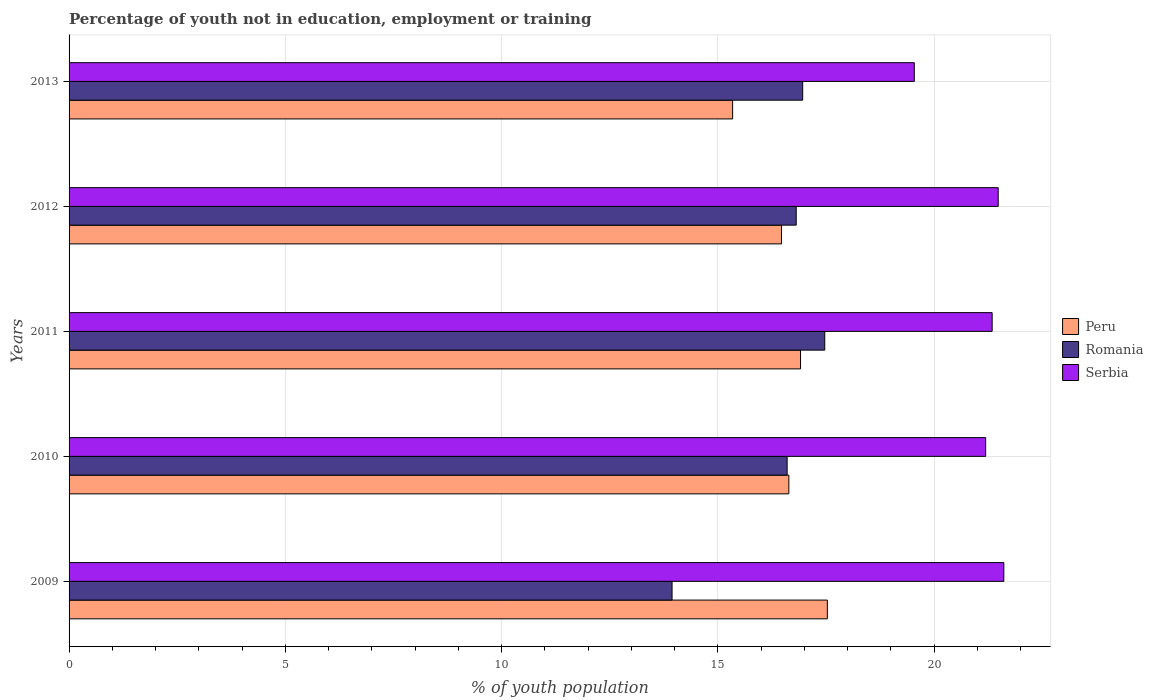How many different coloured bars are there?
Keep it short and to the point. 3. Are the number of bars per tick equal to the number of legend labels?
Provide a short and direct response. Yes. Are the number of bars on each tick of the Y-axis equal?
Offer a terse response. Yes. How many bars are there on the 3rd tick from the top?
Offer a terse response. 3. What is the percentage of unemployed youth population in in Peru in 2009?
Your answer should be very brief. 17.53. Across all years, what is the maximum percentage of unemployed youth population in in Peru?
Your response must be concise. 17.53. Across all years, what is the minimum percentage of unemployed youth population in in Peru?
Your answer should be very brief. 15.34. In which year was the percentage of unemployed youth population in in Peru maximum?
Make the answer very short. 2009. In which year was the percentage of unemployed youth population in in Serbia minimum?
Make the answer very short. 2013. What is the total percentage of unemployed youth population in in Peru in the graph?
Offer a terse response. 82.89. What is the difference between the percentage of unemployed youth population in in Peru in 2009 and that in 2010?
Give a very brief answer. 0.89. What is the difference between the percentage of unemployed youth population in in Romania in 2009 and the percentage of unemployed youth population in in Serbia in 2013?
Your answer should be very brief. -5.6. What is the average percentage of unemployed youth population in in Serbia per year?
Ensure brevity in your answer.  21.03. In the year 2011, what is the difference between the percentage of unemployed youth population in in Serbia and percentage of unemployed youth population in in Peru?
Keep it short and to the point. 4.43. In how many years, is the percentage of unemployed youth population in in Serbia greater than 6 %?
Your answer should be compact. 5. What is the ratio of the percentage of unemployed youth population in in Serbia in 2009 to that in 2012?
Your answer should be very brief. 1.01. What is the difference between the highest and the second highest percentage of unemployed youth population in in Serbia?
Your answer should be very brief. 0.13. What is the difference between the highest and the lowest percentage of unemployed youth population in in Serbia?
Make the answer very short. 2.07. In how many years, is the percentage of unemployed youth population in in Serbia greater than the average percentage of unemployed youth population in in Serbia taken over all years?
Provide a short and direct response. 4. Is the sum of the percentage of unemployed youth population in in Serbia in 2011 and 2012 greater than the maximum percentage of unemployed youth population in in Romania across all years?
Make the answer very short. Yes. What does the 2nd bar from the top in 2012 represents?
Ensure brevity in your answer.  Romania. What does the 3rd bar from the bottom in 2010 represents?
Offer a terse response. Serbia. How many bars are there?
Your answer should be very brief. 15. How many years are there in the graph?
Your response must be concise. 5. What is the difference between two consecutive major ticks on the X-axis?
Offer a terse response. 5. Does the graph contain any zero values?
Your answer should be compact. No. Does the graph contain grids?
Provide a short and direct response. Yes. How many legend labels are there?
Your answer should be very brief. 3. How are the legend labels stacked?
Your response must be concise. Vertical. What is the title of the graph?
Give a very brief answer. Percentage of youth not in education, employment or training. What is the label or title of the X-axis?
Provide a short and direct response. % of youth population. What is the label or title of the Y-axis?
Your response must be concise. Years. What is the % of youth population in Peru in 2009?
Give a very brief answer. 17.53. What is the % of youth population of Romania in 2009?
Offer a very short reply. 13.94. What is the % of youth population in Serbia in 2009?
Provide a succinct answer. 21.61. What is the % of youth population in Peru in 2010?
Offer a terse response. 16.64. What is the % of youth population in Romania in 2010?
Offer a terse response. 16.6. What is the % of youth population of Serbia in 2010?
Provide a short and direct response. 21.19. What is the % of youth population in Peru in 2011?
Provide a short and direct response. 16.91. What is the % of youth population in Romania in 2011?
Your answer should be very brief. 17.47. What is the % of youth population of Serbia in 2011?
Your answer should be very brief. 21.34. What is the % of youth population of Peru in 2012?
Your answer should be compact. 16.47. What is the % of youth population of Romania in 2012?
Offer a very short reply. 16.81. What is the % of youth population of Serbia in 2012?
Offer a very short reply. 21.48. What is the % of youth population in Peru in 2013?
Make the answer very short. 15.34. What is the % of youth population in Romania in 2013?
Your answer should be very brief. 16.96. What is the % of youth population in Serbia in 2013?
Your answer should be very brief. 19.54. Across all years, what is the maximum % of youth population in Peru?
Your answer should be compact. 17.53. Across all years, what is the maximum % of youth population in Romania?
Keep it short and to the point. 17.47. Across all years, what is the maximum % of youth population of Serbia?
Ensure brevity in your answer.  21.61. Across all years, what is the minimum % of youth population in Peru?
Provide a short and direct response. 15.34. Across all years, what is the minimum % of youth population in Romania?
Keep it short and to the point. 13.94. Across all years, what is the minimum % of youth population of Serbia?
Offer a terse response. 19.54. What is the total % of youth population of Peru in the graph?
Offer a terse response. 82.89. What is the total % of youth population of Romania in the graph?
Your answer should be compact. 81.78. What is the total % of youth population of Serbia in the graph?
Make the answer very short. 105.16. What is the difference between the % of youth population of Peru in 2009 and that in 2010?
Give a very brief answer. 0.89. What is the difference between the % of youth population of Romania in 2009 and that in 2010?
Keep it short and to the point. -2.66. What is the difference between the % of youth population in Serbia in 2009 and that in 2010?
Make the answer very short. 0.42. What is the difference between the % of youth population of Peru in 2009 and that in 2011?
Give a very brief answer. 0.62. What is the difference between the % of youth population of Romania in 2009 and that in 2011?
Offer a terse response. -3.53. What is the difference between the % of youth population in Serbia in 2009 and that in 2011?
Ensure brevity in your answer.  0.27. What is the difference between the % of youth population in Peru in 2009 and that in 2012?
Your answer should be compact. 1.06. What is the difference between the % of youth population of Romania in 2009 and that in 2012?
Your response must be concise. -2.87. What is the difference between the % of youth population of Serbia in 2009 and that in 2012?
Keep it short and to the point. 0.13. What is the difference between the % of youth population in Peru in 2009 and that in 2013?
Provide a short and direct response. 2.19. What is the difference between the % of youth population in Romania in 2009 and that in 2013?
Your answer should be compact. -3.02. What is the difference between the % of youth population in Serbia in 2009 and that in 2013?
Provide a short and direct response. 2.07. What is the difference between the % of youth population in Peru in 2010 and that in 2011?
Give a very brief answer. -0.27. What is the difference between the % of youth population of Romania in 2010 and that in 2011?
Offer a terse response. -0.87. What is the difference between the % of youth population in Peru in 2010 and that in 2012?
Make the answer very short. 0.17. What is the difference between the % of youth population in Romania in 2010 and that in 2012?
Keep it short and to the point. -0.21. What is the difference between the % of youth population of Serbia in 2010 and that in 2012?
Your response must be concise. -0.29. What is the difference between the % of youth population of Peru in 2010 and that in 2013?
Make the answer very short. 1.3. What is the difference between the % of youth population of Romania in 2010 and that in 2013?
Provide a short and direct response. -0.36. What is the difference between the % of youth population of Serbia in 2010 and that in 2013?
Your response must be concise. 1.65. What is the difference between the % of youth population of Peru in 2011 and that in 2012?
Your answer should be very brief. 0.44. What is the difference between the % of youth population of Romania in 2011 and that in 2012?
Your answer should be compact. 0.66. What is the difference between the % of youth population in Serbia in 2011 and that in 2012?
Provide a succinct answer. -0.14. What is the difference between the % of youth population of Peru in 2011 and that in 2013?
Your answer should be very brief. 1.57. What is the difference between the % of youth population of Romania in 2011 and that in 2013?
Provide a short and direct response. 0.51. What is the difference between the % of youth population in Serbia in 2011 and that in 2013?
Ensure brevity in your answer.  1.8. What is the difference between the % of youth population in Peru in 2012 and that in 2013?
Give a very brief answer. 1.13. What is the difference between the % of youth population of Romania in 2012 and that in 2013?
Give a very brief answer. -0.15. What is the difference between the % of youth population in Serbia in 2012 and that in 2013?
Keep it short and to the point. 1.94. What is the difference between the % of youth population of Peru in 2009 and the % of youth population of Romania in 2010?
Your answer should be very brief. 0.93. What is the difference between the % of youth population of Peru in 2009 and the % of youth population of Serbia in 2010?
Offer a terse response. -3.66. What is the difference between the % of youth population of Romania in 2009 and the % of youth population of Serbia in 2010?
Keep it short and to the point. -7.25. What is the difference between the % of youth population of Peru in 2009 and the % of youth population of Romania in 2011?
Give a very brief answer. 0.06. What is the difference between the % of youth population in Peru in 2009 and the % of youth population in Serbia in 2011?
Offer a very short reply. -3.81. What is the difference between the % of youth population in Peru in 2009 and the % of youth population in Romania in 2012?
Your answer should be compact. 0.72. What is the difference between the % of youth population of Peru in 2009 and the % of youth population of Serbia in 2012?
Offer a terse response. -3.95. What is the difference between the % of youth population of Romania in 2009 and the % of youth population of Serbia in 2012?
Your answer should be compact. -7.54. What is the difference between the % of youth population of Peru in 2009 and the % of youth population of Romania in 2013?
Provide a short and direct response. 0.57. What is the difference between the % of youth population in Peru in 2009 and the % of youth population in Serbia in 2013?
Ensure brevity in your answer.  -2.01. What is the difference between the % of youth population in Peru in 2010 and the % of youth population in Romania in 2011?
Give a very brief answer. -0.83. What is the difference between the % of youth population in Peru in 2010 and the % of youth population in Serbia in 2011?
Make the answer very short. -4.7. What is the difference between the % of youth population in Romania in 2010 and the % of youth population in Serbia in 2011?
Keep it short and to the point. -4.74. What is the difference between the % of youth population in Peru in 2010 and the % of youth population in Romania in 2012?
Give a very brief answer. -0.17. What is the difference between the % of youth population of Peru in 2010 and the % of youth population of Serbia in 2012?
Offer a very short reply. -4.84. What is the difference between the % of youth population of Romania in 2010 and the % of youth population of Serbia in 2012?
Keep it short and to the point. -4.88. What is the difference between the % of youth population in Peru in 2010 and the % of youth population in Romania in 2013?
Make the answer very short. -0.32. What is the difference between the % of youth population in Peru in 2010 and the % of youth population in Serbia in 2013?
Offer a very short reply. -2.9. What is the difference between the % of youth population in Romania in 2010 and the % of youth population in Serbia in 2013?
Give a very brief answer. -2.94. What is the difference between the % of youth population of Peru in 2011 and the % of youth population of Romania in 2012?
Keep it short and to the point. 0.1. What is the difference between the % of youth population of Peru in 2011 and the % of youth population of Serbia in 2012?
Your response must be concise. -4.57. What is the difference between the % of youth population of Romania in 2011 and the % of youth population of Serbia in 2012?
Your answer should be very brief. -4.01. What is the difference between the % of youth population of Peru in 2011 and the % of youth population of Serbia in 2013?
Ensure brevity in your answer.  -2.63. What is the difference between the % of youth population of Romania in 2011 and the % of youth population of Serbia in 2013?
Offer a terse response. -2.07. What is the difference between the % of youth population of Peru in 2012 and the % of youth population of Romania in 2013?
Make the answer very short. -0.49. What is the difference between the % of youth population of Peru in 2012 and the % of youth population of Serbia in 2013?
Provide a short and direct response. -3.07. What is the difference between the % of youth population in Romania in 2012 and the % of youth population in Serbia in 2013?
Ensure brevity in your answer.  -2.73. What is the average % of youth population in Peru per year?
Your response must be concise. 16.58. What is the average % of youth population in Romania per year?
Your response must be concise. 16.36. What is the average % of youth population of Serbia per year?
Make the answer very short. 21.03. In the year 2009, what is the difference between the % of youth population of Peru and % of youth population of Romania?
Offer a terse response. 3.59. In the year 2009, what is the difference between the % of youth population in Peru and % of youth population in Serbia?
Provide a succinct answer. -4.08. In the year 2009, what is the difference between the % of youth population of Romania and % of youth population of Serbia?
Offer a terse response. -7.67. In the year 2010, what is the difference between the % of youth population in Peru and % of youth population in Romania?
Your response must be concise. 0.04. In the year 2010, what is the difference between the % of youth population in Peru and % of youth population in Serbia?
Ensure brevity in your answer.  -4.55. In the year 2010, what is the difference between the % of youth population of Romania and % of youth population of Serbia?
Make the answer very short. -4.59. In the year 2011, what is the difference between the % of youth population of Peru and % of youth population of Romania?
Your response must be concise. -0.56. In the year 2011, what is the difference between the % of youth population in Peru and % of youth population in Serbia?
Keep it short and to the point. -4.43. In the year 2011, what is the difference between the % of youth population in Romania and % of youth population in Serbia?
Offer a very short reply. -3.87. In the year 2012, what is the difference between the % of youth population in Peru and % of youth population in Romania?
Your answer should be compact. -0.34. In the year 2012, what is the difference between the % of youth population of Peru and % of youth population of Serbia?
Keep it short and to the point. -5.01. In the year 2012, what is the difference between the % of youth population of Romania and % of youth population of Serbia?
Offer a terse response. -4.67. In the year 2013, what is the difference between the % of youth population of Peru and % of youth population of Romania?
Keep it short and to the point. -1.62. In the year 2013, what is the difference between the % of youth population of Romania and % of youth population of Serbia?
Your answer should be very brief. -2.58. What is the ratio of the % of youth population in Peru in 2009 to that in 2010?
Keep it short and to the point. 1.05. What is the ratio of the % of youth population in Romania in 2009 to that in 2010?
Ensure brevity in your answer.  0.84. What is the ratio of the % of youth population of Serbia in 2009 to that in 2010?
Keep it short and to the point. 1.02. What is the ratio of the % of youth population in Peru in 2009 to that in 2011?
Offer a terse response. 1.04. What is the ratio of the % of youth population in Romania in 2009 to that in 2011?
Ensure brevity in your answer.  0.8. What is the ratio of the % of youth population of Serbia in 2009 to that in 2011?
Your response must be concise. 1.01. What is the ratio of the % of youth population in Peru in 2009 to that in 2012?
Your answer should be compact. 1.06. What is the ratio of the % of youth population of Romania in 2009 to that in 2012?
Provide a succinct answer. 0.83. What is the ratio of the % of youth population in Peru in 2009 to that in 2013?
Your answer should be very brief. 1.14. What is the ratio of the % of youth population of Romania in 2009 to that in 2013?
Provide a short and direct response. 0.82. What is the ratio of the % of youth population in Serbia in 2009 to that in 2013?
Your answer should be compact. 1.11. What is the ratio of the % of youth population in Romania in 2010 to that in 2011?
Ensure brevity in your answer.  0.95. What is the ratio of the % of youth population of Serbia in 2010 to that in 2011?
Your answer should be compact. 0.99. What is the ratio of the % of youth population of Peru in 2010 to that in 2012?
Offer a terse response. 1.01. What is the ratio of the % of youth population in Romania in 2010 to that in 2012?
Your answer should be very brief. 0.99. What is the ratio of the % of youth population in Serbia in 2010 to that in 2012?
Your response must be concise. 0.99. What is the ratio of the % of youth population in Peru in 2010 to that in 2013?
Offer a terse response. 1.08. What is the ratio of the % of youth population of Romania in 2010 to that in 2013?
Provide a short and direct response. 0.98. What is the ratio of the % of youth population in Serbia in 2010 to that in 2013?
Your response must be concise. 1.08. What is the ratio of the % of youth population of Peru in 2011 to that in 2012?
Offer a very short reply. 1.03. What is the ratio of the % of youth population in Romania in 2011 to that in 2012?
Make the answer very short. 1.04. What is the ratio of the % of youth population in Serbia in 2011 to that in 2012?
Your response must be concise. 0.99. What is the ratio of the % of youth population of Peru in 2011 to that in 2013?
Keep it short and to the point. 1.1. What is the ratio of the % of youth population in Romania in 2011 to that in 2013?
Make the answer very short. 1.03. What is the ratio of the % of youth population of Serbia in 2011 to that in 2013?
Keep it short and to the point. 1.09. What is the ratio of the % of youth population in Peru in 2012 to that in 2013?
Your response must be concise. 1.07. What is the ratio of the % of youth population of Romania in 2012 to that in 2013?
Offer a very short reply. 0.99. What is the ratio of the % of youth population in Serbia in 2012 to that in 2013?
Your answer should be very brief. 1.1. What is the difference between the highest and the second highest % of youth population in Peru?
Your answer should be compact. 0.62. What is the difference between the highest and the second highest % of youth population in Romania?
Your answer should be compact. 0.51. What is the difference between the highest and the second highest % of youth population in Serbia?
Give a very brief answer. 0.13. What is the difference between the highest and the lowest % of youth population in Peru?
Give a very brief answer. 2.19. What is the difference between the highest and the lowest % of youth population in Romania?
Provide a short and direct response. 3.53. What is the difference between the highest and the lowest % of youth population of Serbia?
Give a very brief answer. 2.07. 